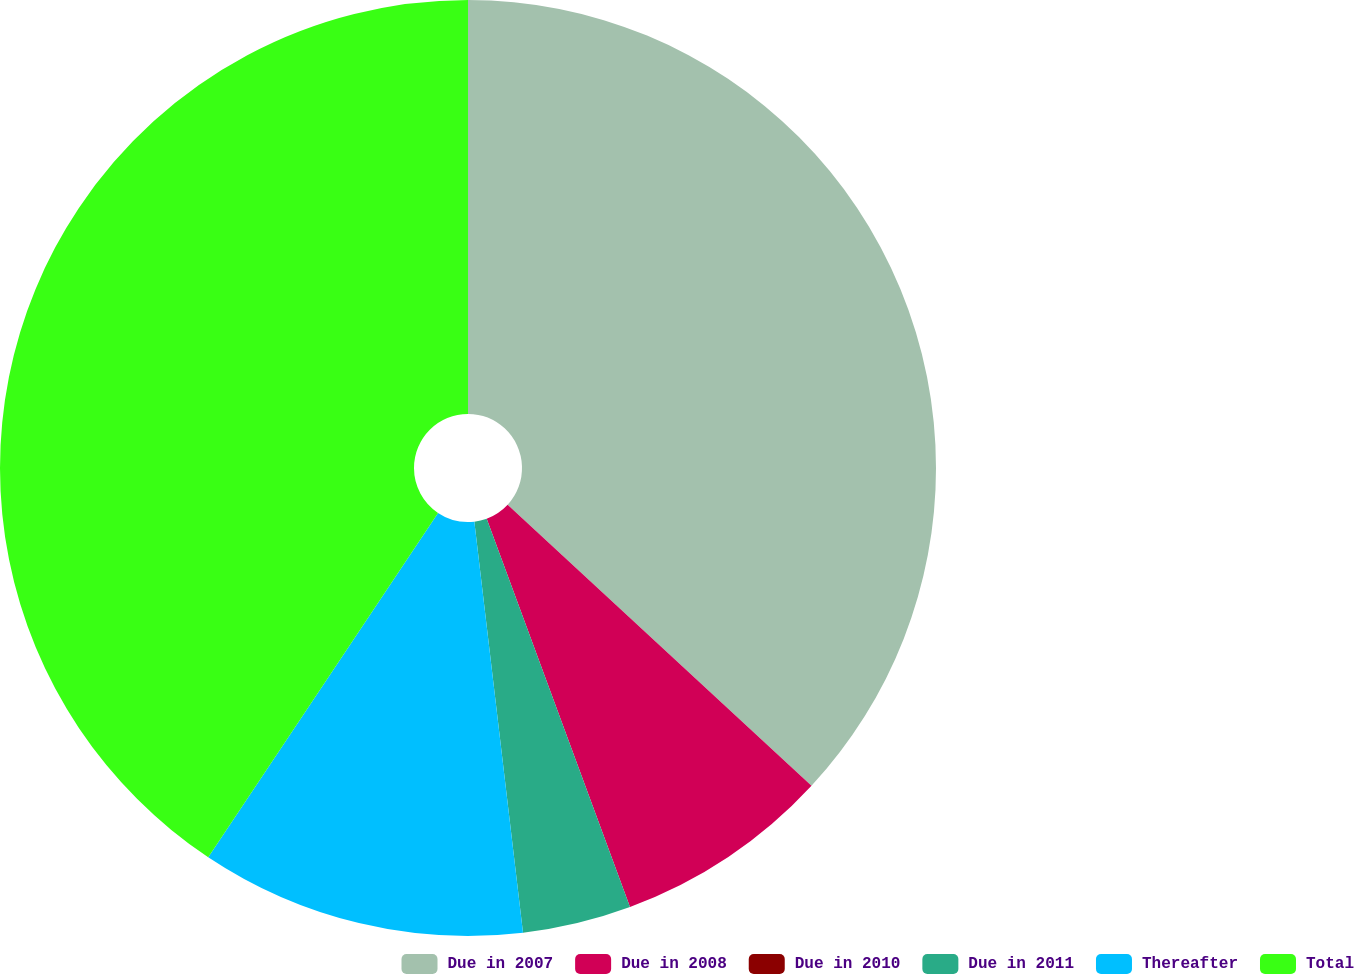Convert chart. <chart><loc_0><loc_0><loc_500><loc_500><pie_chart><fcel>Due in 2007<fcel>Due in 2008<fcel>Due in 2010<fcel>Due in 2011<fcel>Thereafter<fcel>Total<nl><fcel>36.88%<fcel>7.49%<fcel>0.0%<fcel>3.75%<fcel>11.24%<fcel>40.63%<nl></chart> 